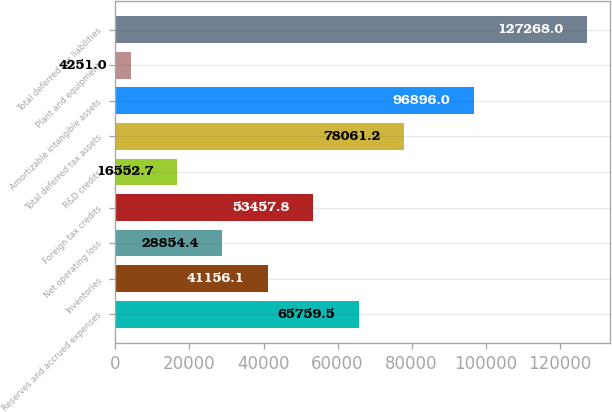<chart> <loc_0><loc_0><loc_500><loc_500><bar_chart><fcel>Reserves and accrued expenses<fcel>Inventories<fcel>Net operating loss<fcel>Foreign tax credits<fcel>R&D credits<fcel>Total deferred tax assets<fcel>Amortizable intangible assets<fcel>Plant and equipment<fcel>Total deferred tax liabilities<nl><fcel>65759.5<fcel>41156.1<fcel>28854.4<fcel>53457.8<fcel>16552.7<fcel>78061.2<fcel>96896<fcel>4251<fcel>127268<nl></chart> 